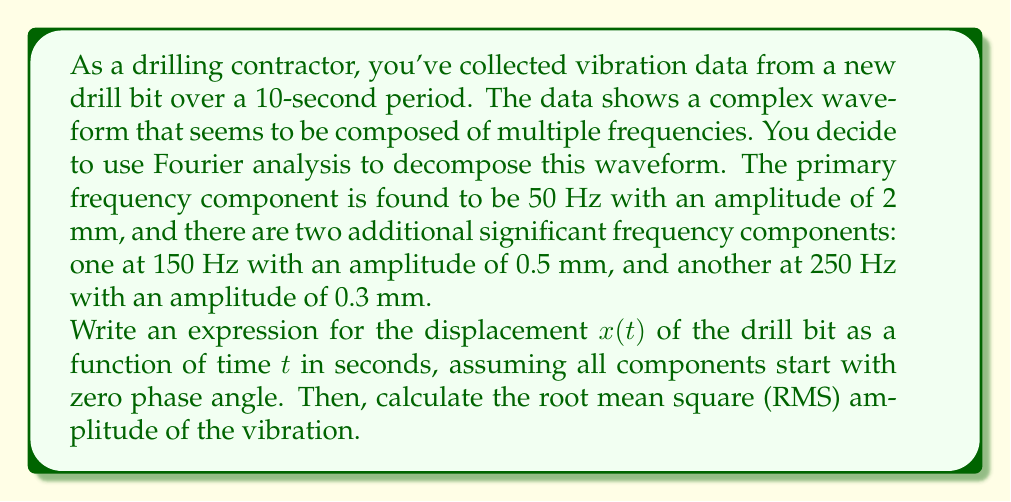What is the answer to this math problem? Let's approach this problem step by step:

1) First, we need to write the expression for $x(t)$. The general form of a cosine wave is:

   $A \cos(2\pi ft)$

   where $A$ is the amplitude, $f$ is the frequency, and $t$ is time.

2) We have three components to add:
   - 50 Hz with amplitude 2 mm
   - 150 Hz with amplitude 0.5 mm
   - 250 Hz with amplitude 0.3 mm

3) Therefore, our expression for $x(t)$ is:

   $x(t) = 2\cos(2\pi 50t) + 0.5\cos(2\pi 150t) + 0.3\cos(2\pi 250t)$

4) Now, to calculate the RMS amplitude, we use the formula:

   $RMS = \sqrt{\frac{A_1^2 + A_2^2 + ... + A_n^2}{2}}$

   where $A_1, A_2, ..., A_n$ are the amplitudes of each component.

5) Substituting our values:

   $RMS = \sqrt{\frac{2^2 + 0.5^2 + 0.3^2}{2}}$

6) Simplifying:

   $RMS = \sqrt{\frac{4 + 0.25 + 0.09}{2}} = \sqrt{\frac{4.34}{2}} = \sqrt{2.17} \approx 1.47$ mm

Therefore, the RMS amplitude of the vibration is approximately 1.47 mm.
Answer: $x(t) = 2\cos(2\pi 50t) + 0.5\cos(2\pi 150t) + 0.3\cos(2\pi 250t)$

RMS amplitude $\approx 1.47$ mm 